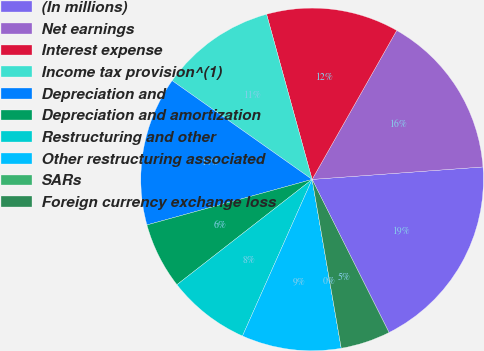Convert chart. <chart><loc_0><loc_0><loc_500><loc_500><pie_chart><fcel>(In millions)<fcel>Net earnings<fcel>Interest expense<fcel>Income tax provision^(1)<fcel>Depreciation and<fcel>Depreciation and amortization<fcel>Restructuring and other<fcel>Other restructuring associated<fcel>SARs<fcel>Foreign currency exchange loss<nl><fcel>18.75%<fcel>15.62%<fcel>12.5%<fcel>10.94%<fcel>14.06%<fcel>6.25%<fcel>7.81%<fcel>9.38%<fcel>0.0%<fcel>4.69%<nl></chart> 